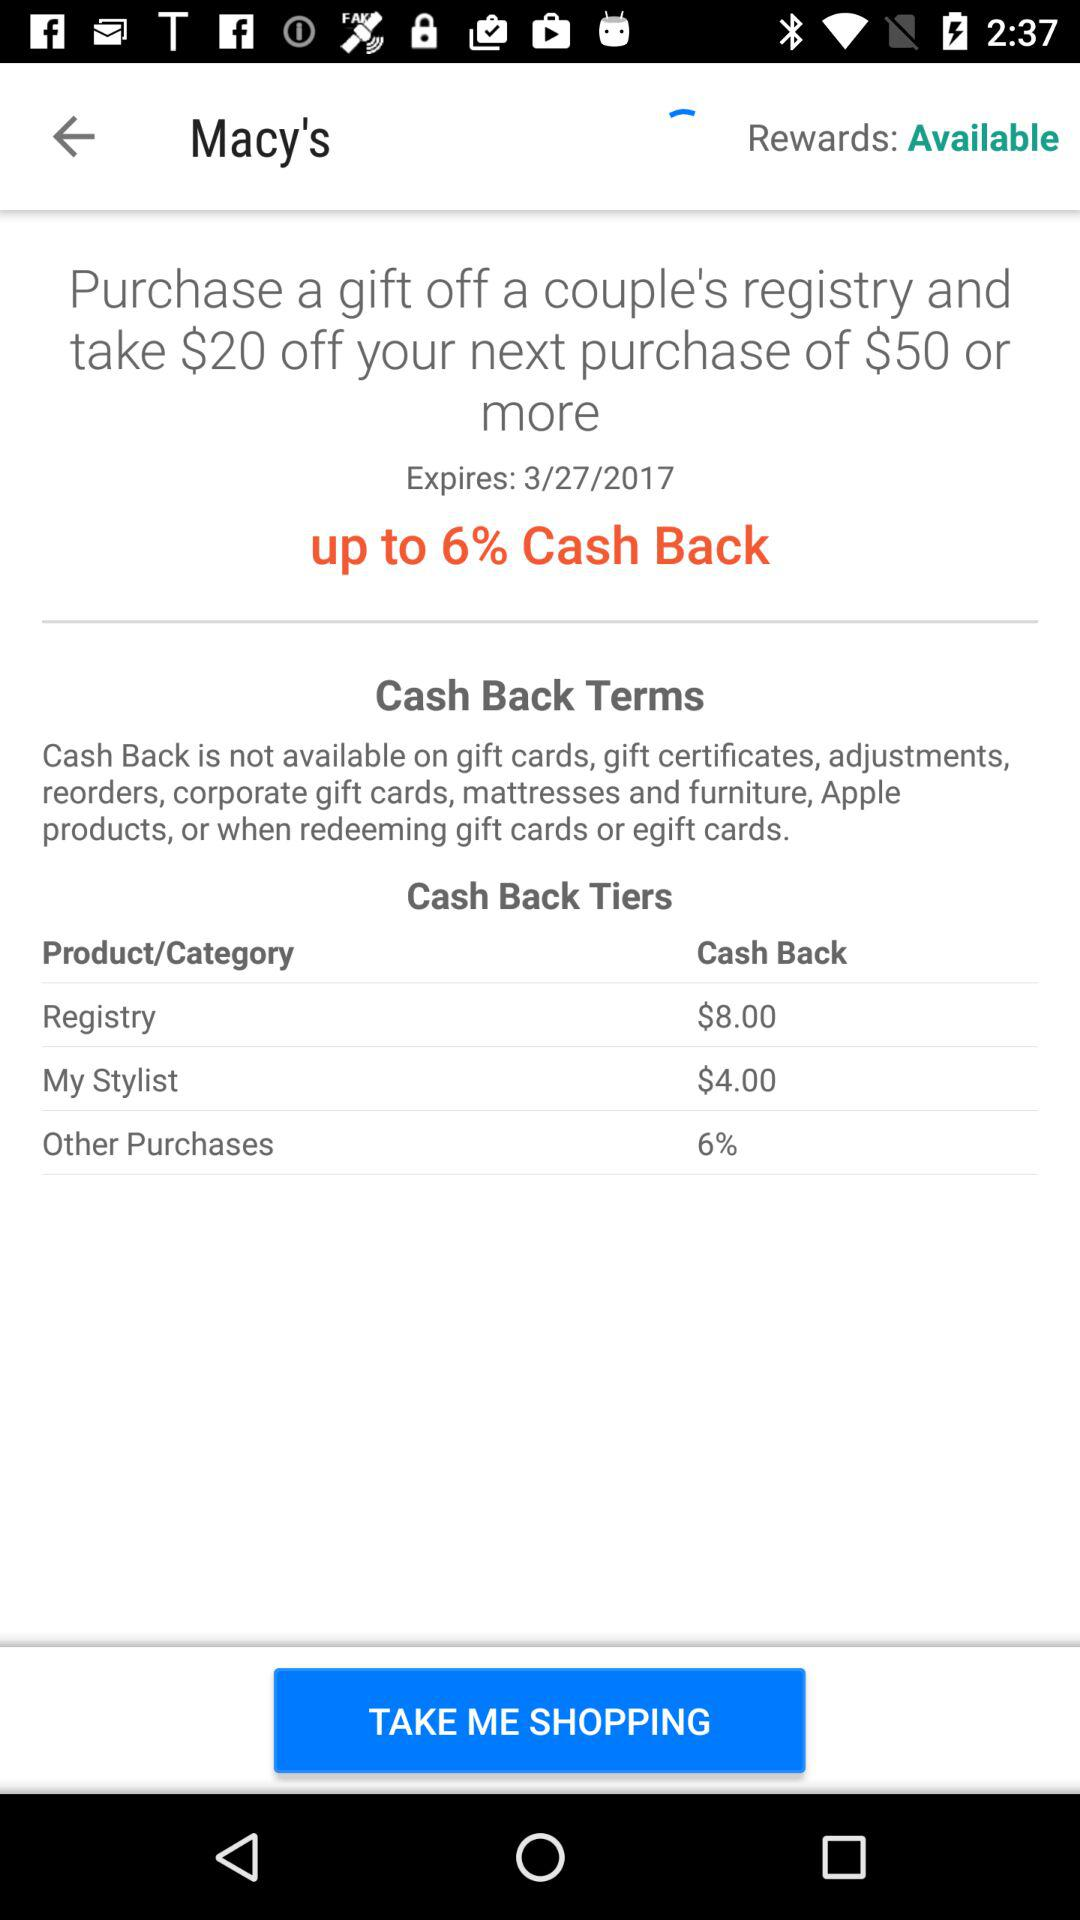How much cashback will we get if we buy something else? You will get 6% cashback if you buy something else. 